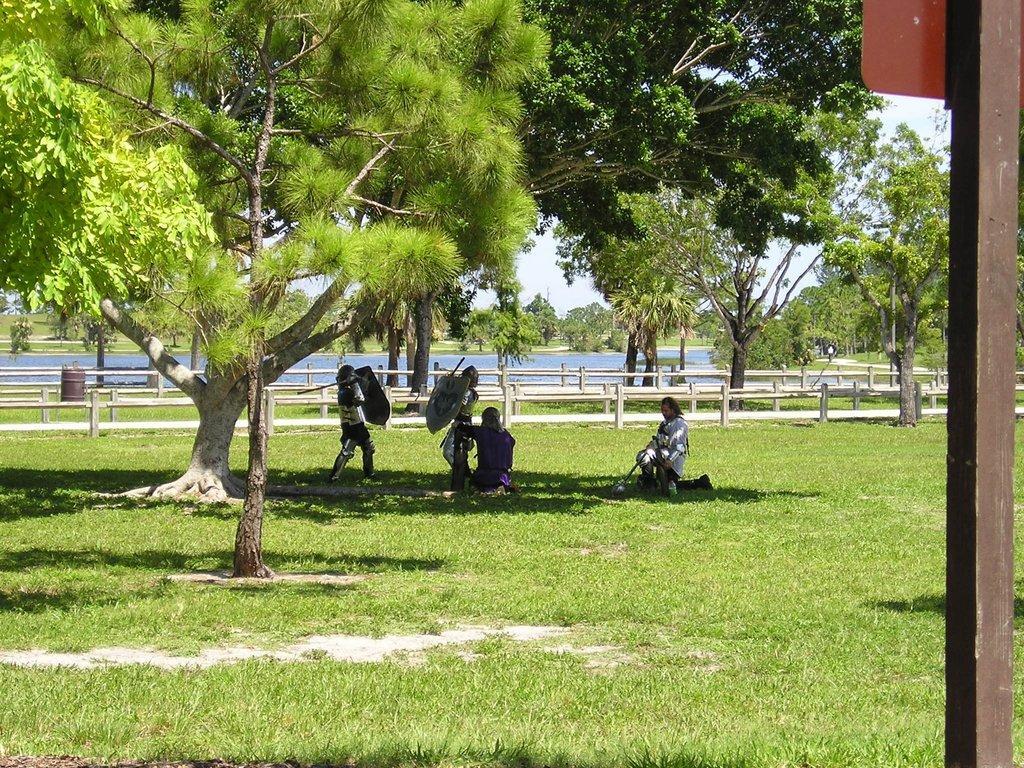Please provide a concise description of this image. In this picture we can see some trees and grass, we can see a few people are sitting on the grass. 